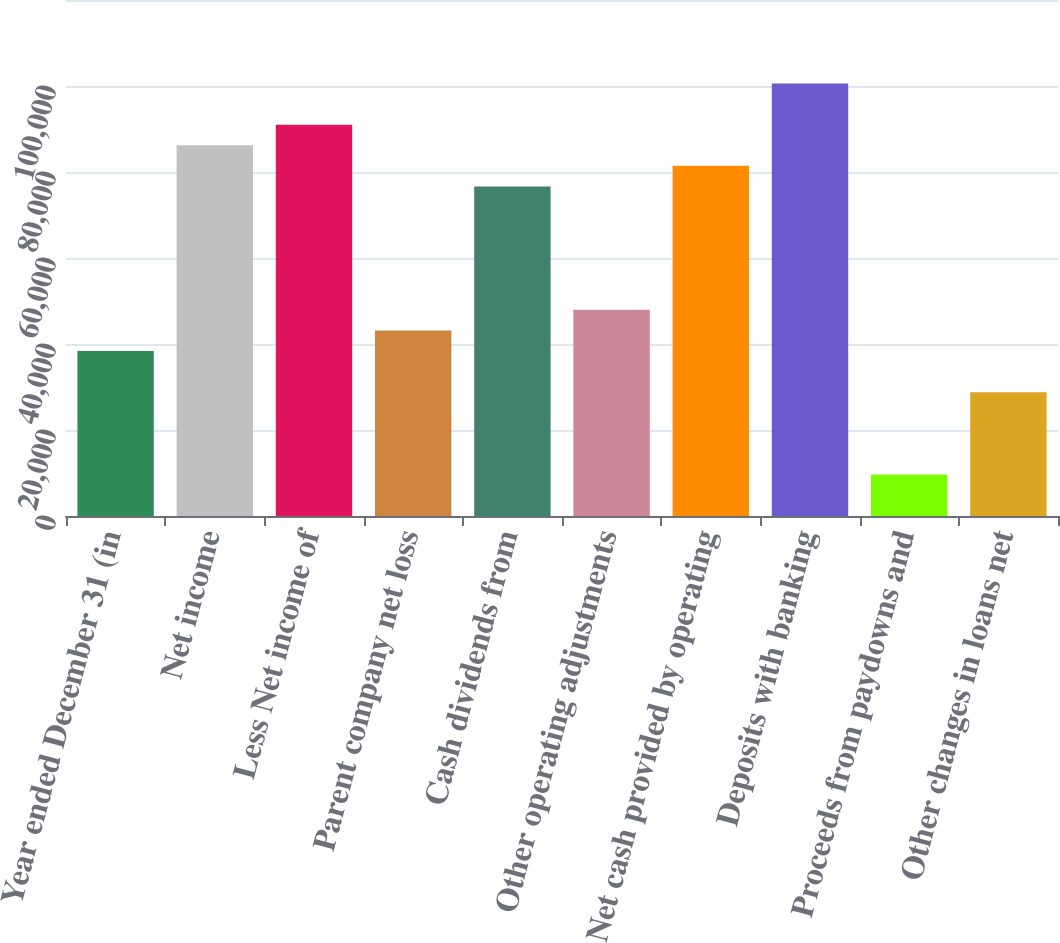<chart> <loc_0><loc_0><loc_500><loc_500><bar_chart><fcel>Year ended December 31 (in<fcel>Net income<fcel>Less Net income of<fcel>Parent company net loss<fcel>Cash dividends from<fcel>Other operating adjustments<fcel>Net cash provided by operating<fcel>Deposits with banking<fcel>Proceeds from paydowns and<fcel>Other changes in loans net<nl><fcel>38364.4<fcel>86227.4<fcel>91013.7<fcel>43150.7<fcel>76654.8<fcel>47937<fcel>81441.1<fcel>100586<fcel>9646.6<fcel>28791.8<nl></chart> 